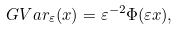<formula> <loc_0><loc_0><loc_500><loc_500>\ G V a r _ { \varepsilon } ( x ) = \varepsilon ^ { - 2 } \Phi ( \varepsilon x ) ,</formula> 